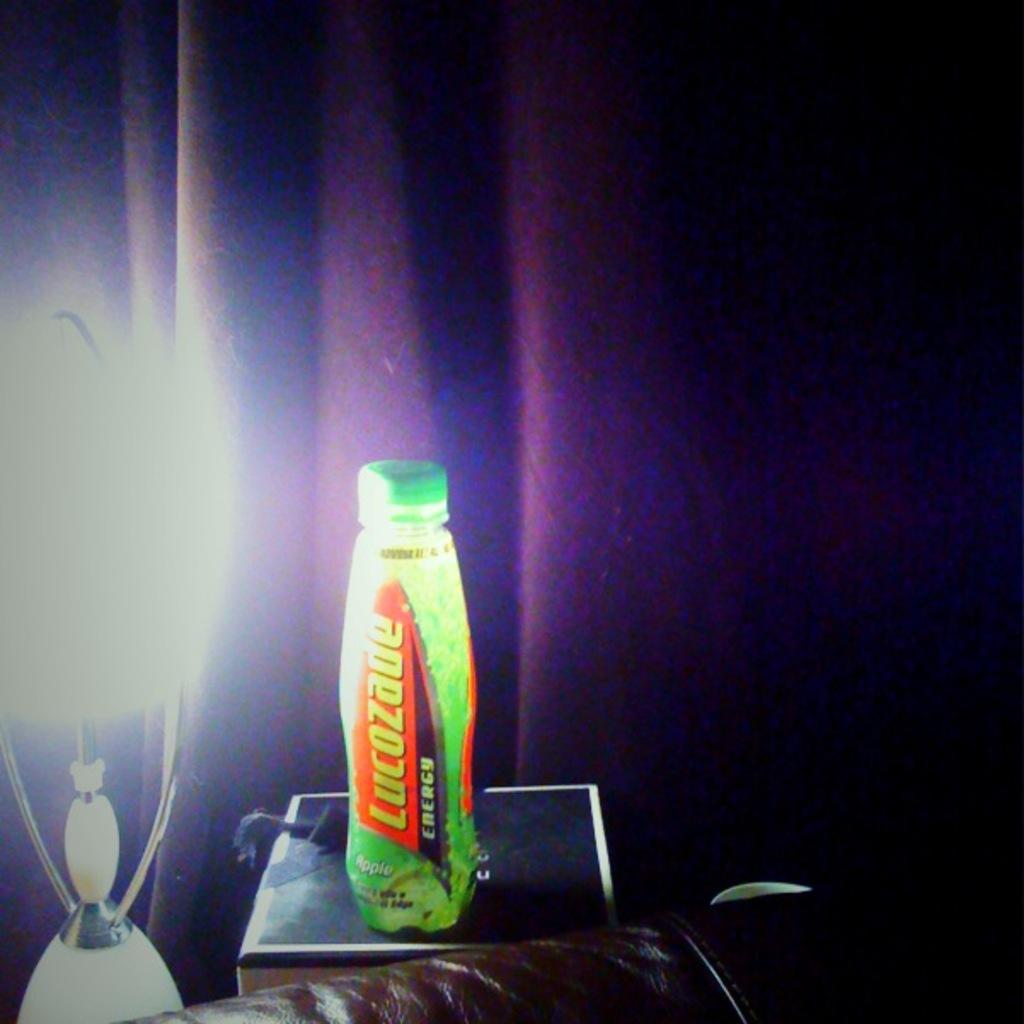What is in the bottle?
Provide a short and direct response. Lucozade. What's the brand name of the beverage?
Provide a short and direct response. Lucozade. 